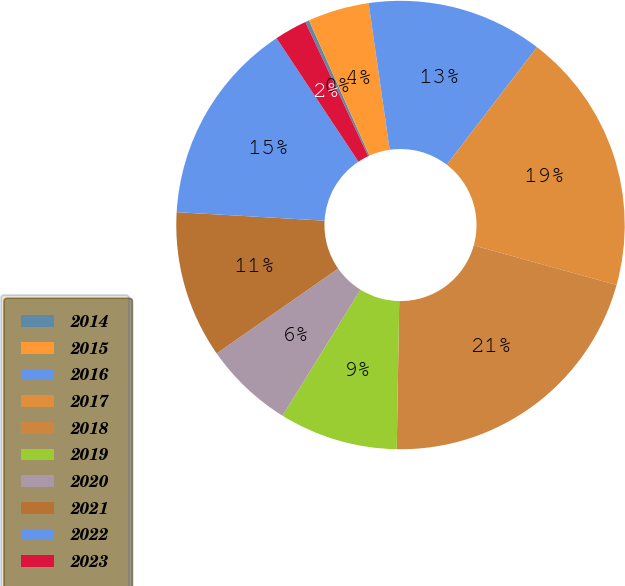Convert chart to OTSL. <chart><loc_0><loc_0><loc_500><loc_500><pie_chart><fcel>2014<fcel>2015<fcel>2016<fcel>2017<fcel>2018<fcel>2019<fcel>2020<fcel>2021<fcel>2022<fcel>2023<nl><fcel>0.28%<fcel>4.42%<fcel>12.69%<fcel>18.89%<fcel>20.96%<fcel>8.55%<fcel>6.48%<fcel>10.62%<fcel>14.76%<fcel>2.35%<nl></chart> 